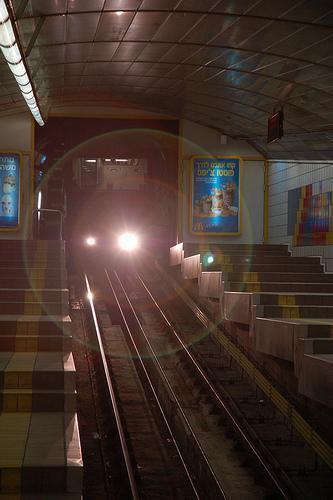How many trains are there?
Give a very brief answer. 1. 